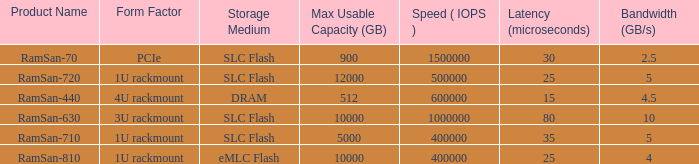List the range distroration for the ramsan-630 3U rackmount. 